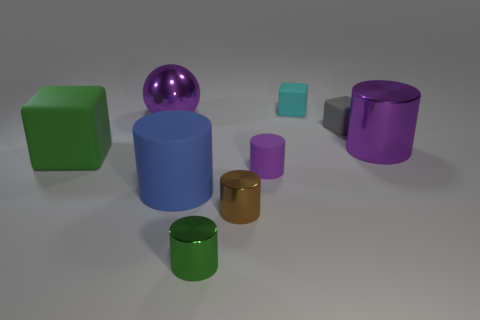There is a ball; does it have the same size as the purple rubber thing that is to the right of the tiny brown object?
Your answer should be very brief. No. There is a brown object that is the same shape as the large blue object; what is its material?
Offer a terse response. Metal. Does the purple cylinder that is to the left of the small gray thing have the same size as the purple cylinder to the right of the gray block?
Give a very brief answer. No. What is the big cylinder that is behind the tiny matte thing that is on the left side of the cyan matte cube made of?
Make the answer very short. Metal. Are there an equal number of big purple shiny balls that are in front of the large green block and small gray rubber balls?
Your response must be concise. Yes. What number of other things are there of the same size as the cyan block?
Offer a terse response. 4. Are the large thing on the right side of the tiny gray rubber cube and the large object that is in front of the tiny purple matte thing made of the same material?
Your answer should be very brief. No. There is a purple metallic object that is right of the large thing that is in front of the big cube; how big is it?
Make the answer very short. Large. Are there any small matte things that have the same color as the large shiny sphere?
Offer a very short reply. Yes. Do the matte block that is on the left side of the purple ball and the small object in front of the tiny brown metallic cylinder have the same color?
Your response must be concise. Yes. 